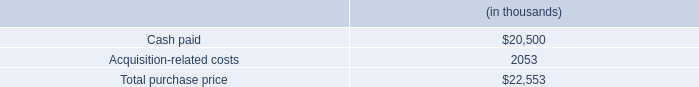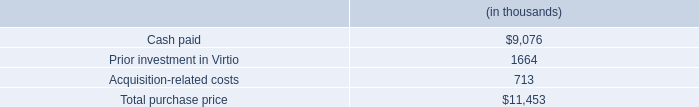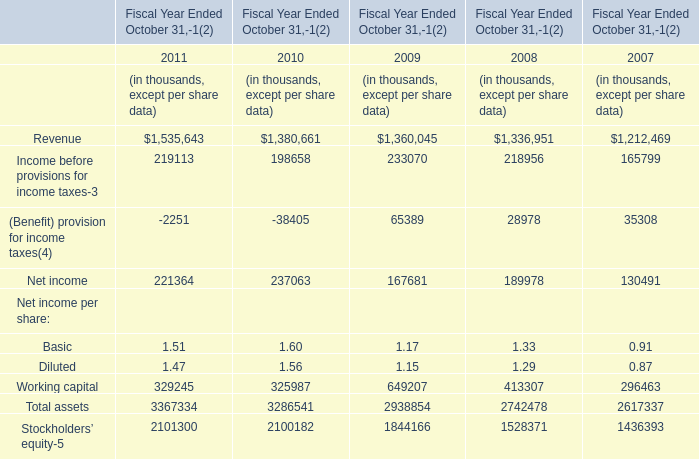what is the percentage of existing technology among the total intangible assets? 
Computations: (3.9 / 6.0)
Answer: 0.65. 